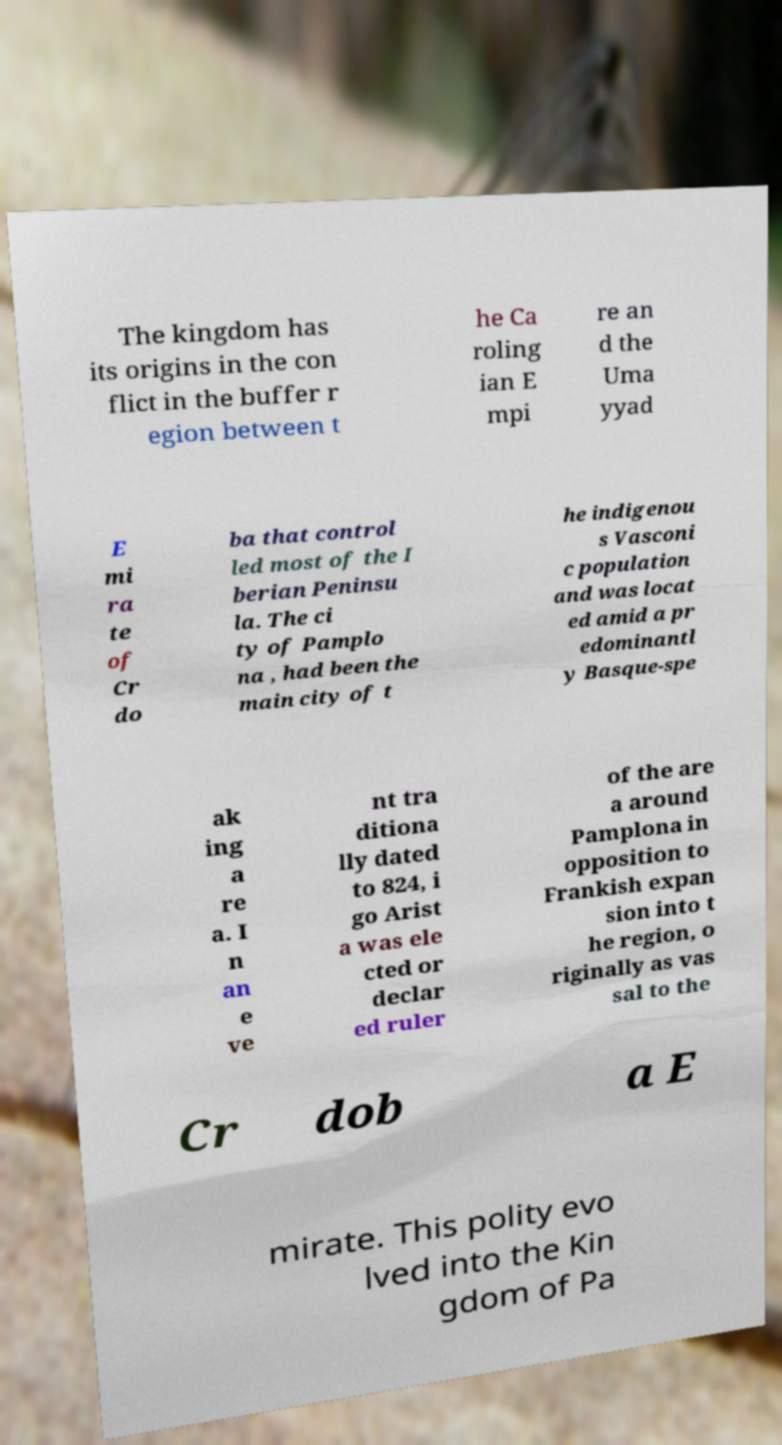Could you assist in decoding the text presented in this image and type it out clearly? The kingdom has its origins in the con flict in the buffer r egion between t he Ca roling ian E mpi re an d the Uma yyad E mi ra te of Cr do ba that control led most of the I berian Peninsu la. The ci ty of Pamplo na , had been the main city of t he indigenou s Vasconi c population and was locat ed amid a pr edominantl y Basque-spe ak ing a re a. I n an e ve nt tra ditiona lly dated to 824, i go Arist a was ele cted or declar ed ruler of the are a around Pamplona in opposition to Frankish expan sion into t he region, o riginally as vas sal to the Cr dob a E mirate. This polity evo lved into the Kin gdom of Pa 